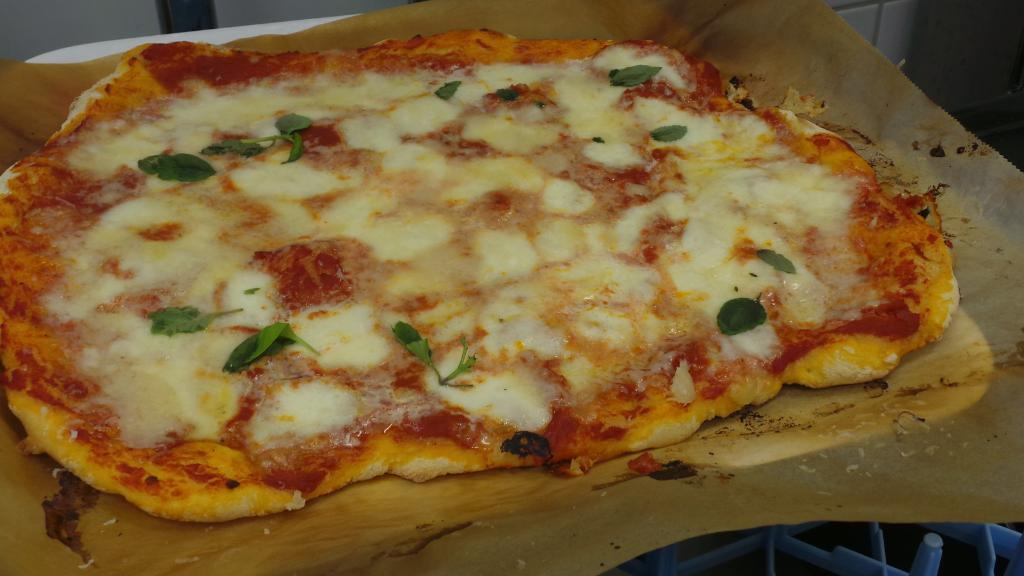What is the main object on the chopping board in the image? A pizza is present on the chopping board in the image. What is the material of the chopping board? The chopping board is made of wood. How would you describe the background of the image? The background of the image is dark. Can you see any tigers or spiders on the wooden chopping board in the image? No, there are no tigers or spiders present on the wooden chopping board in the image. Is there a record player visible in the image? No, there is no record player visible in the image. 